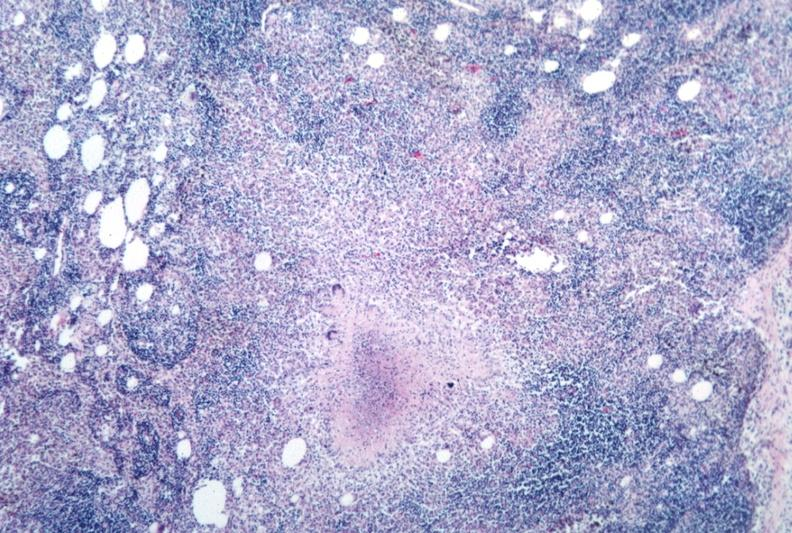what is present?
Answer the question using a single word or phrase. Tuberculosis 